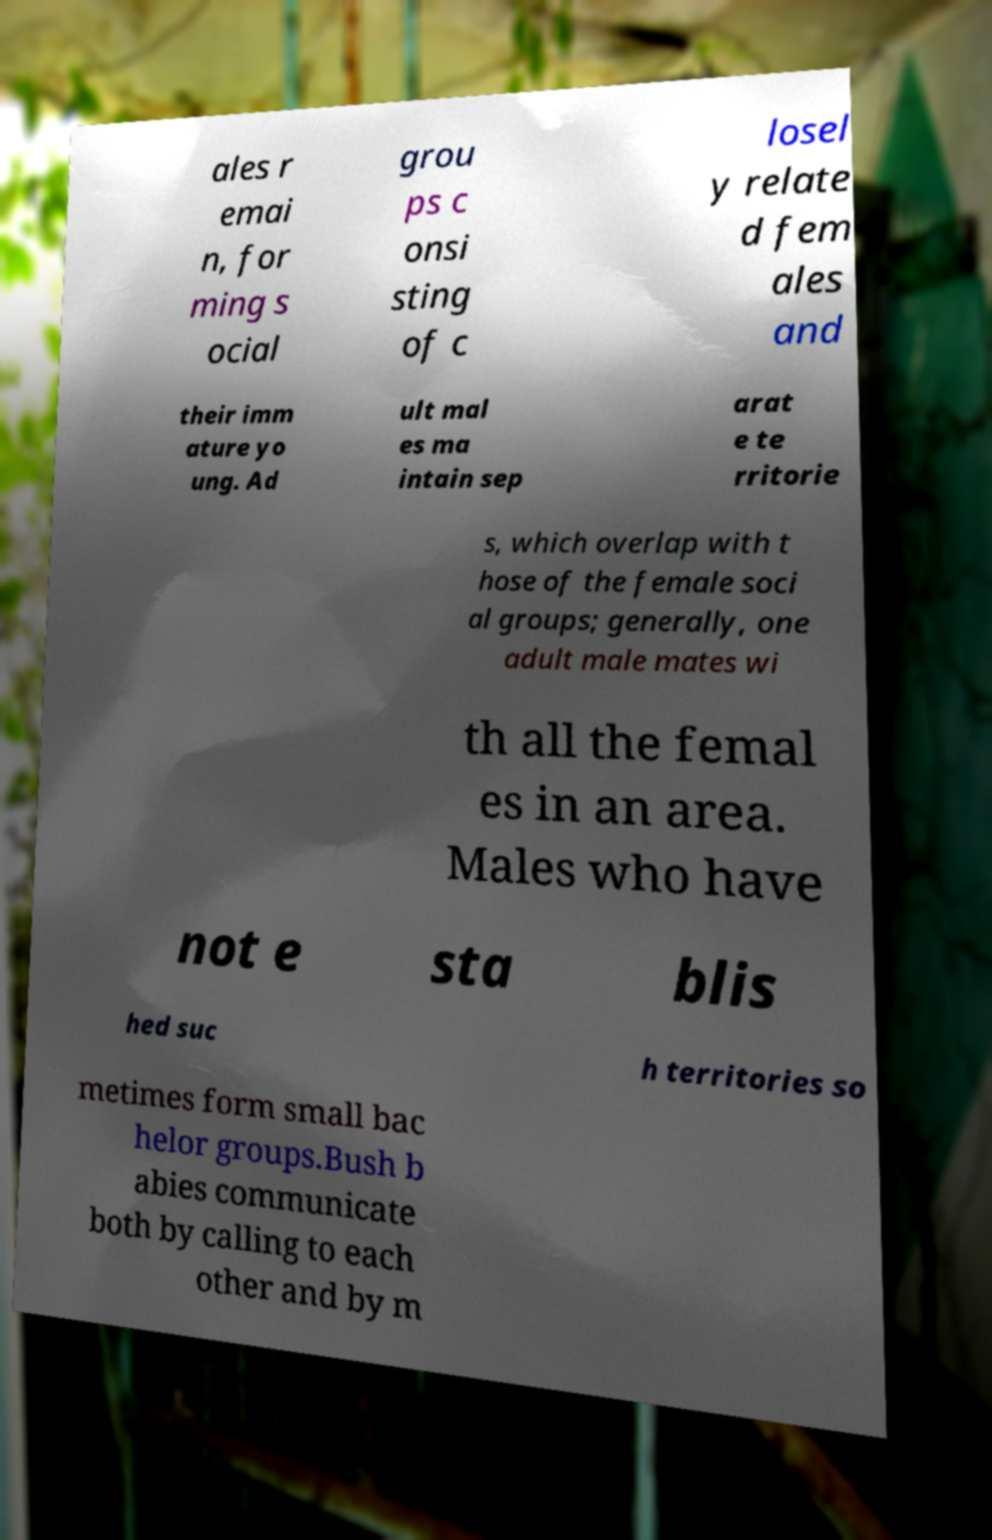What messages or text are displayed in this image? I need them in a readable, typed format. ales r emai n, for ming s ocial grou ps c onsi sting of c losel y relate d fem ales and their imm ature yo ung. Ad ult mal es ma intain sep arat e te rritorie s, which overlap with t hose of the female soci al groups; generally, one adult male mates wi th all the femal es in an area. Males who have not e sta blis hed suc h territories so metimes form small bac helor groups.Bush b abies communicate both by calling to each other and by m 